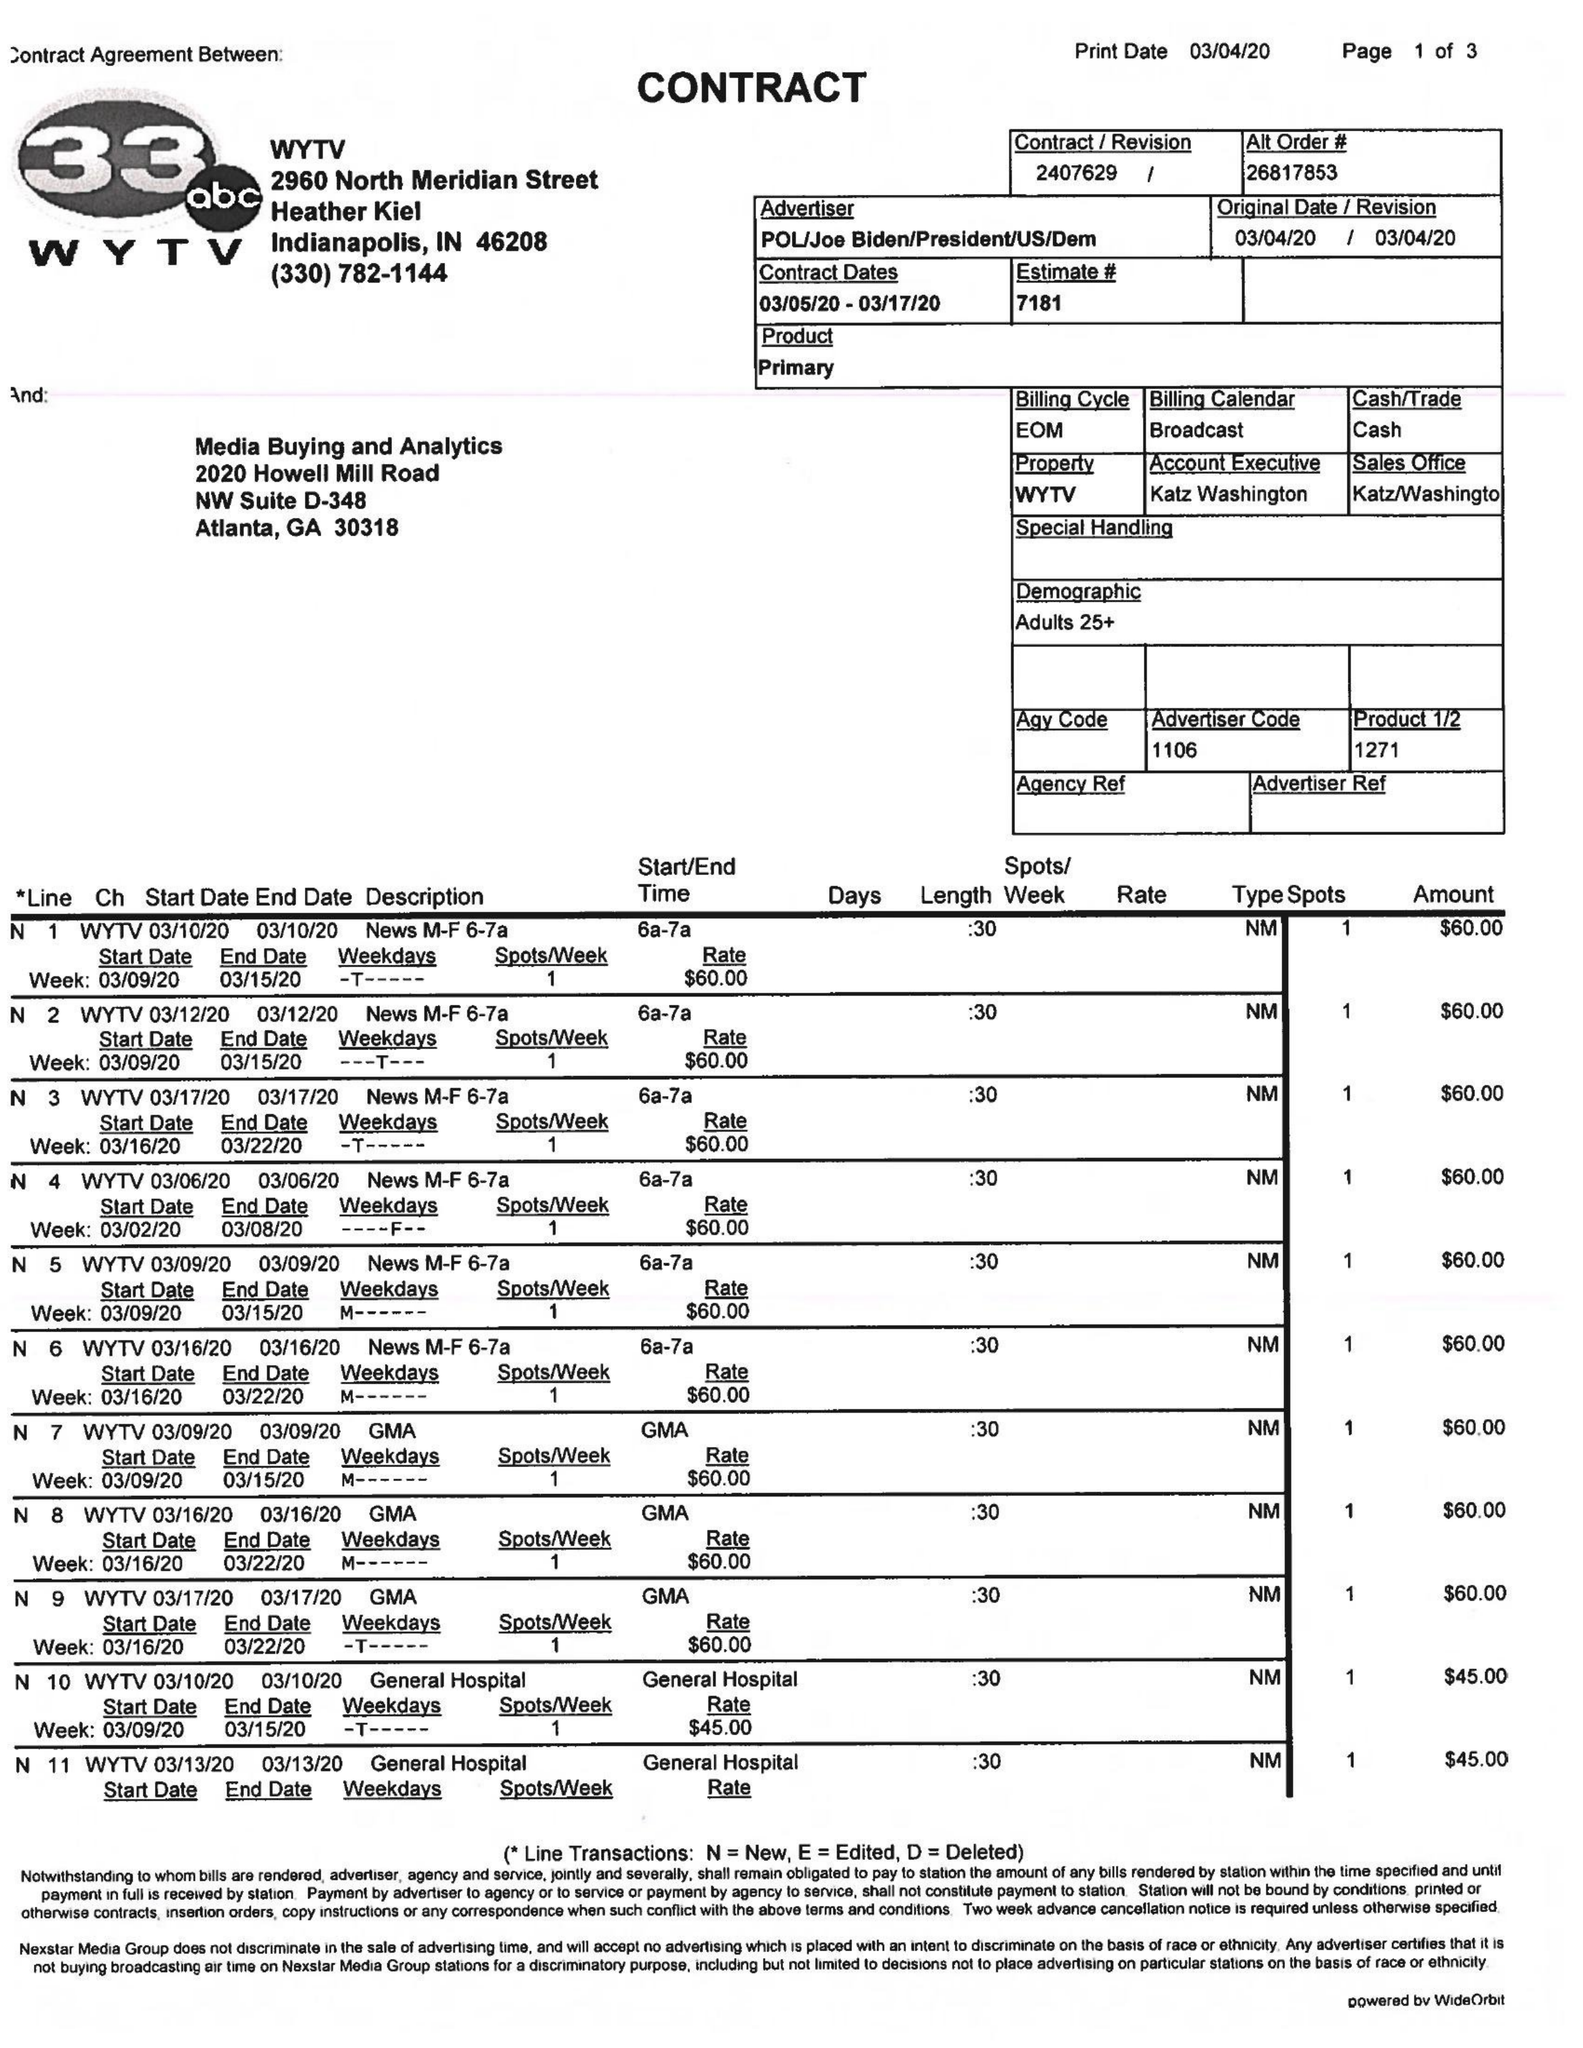What is the value for the contract_num?
Answer the question using a single word or phrase. 2407629 